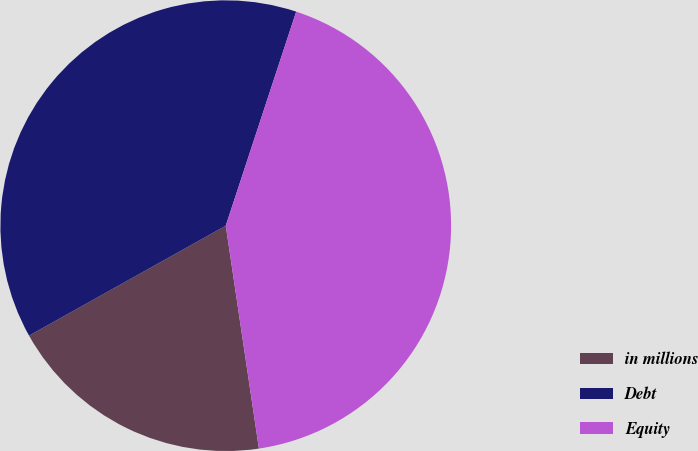Convert chart to OTSL. <chart><loc_0><loc_0><loc_500><loc_500><pie_chart><fcel>in millions<fcel>Debt<fcel>Equity<nl><fcel>19.24%<fcel>38.17%<fcel>42.59%<nl></chart> 